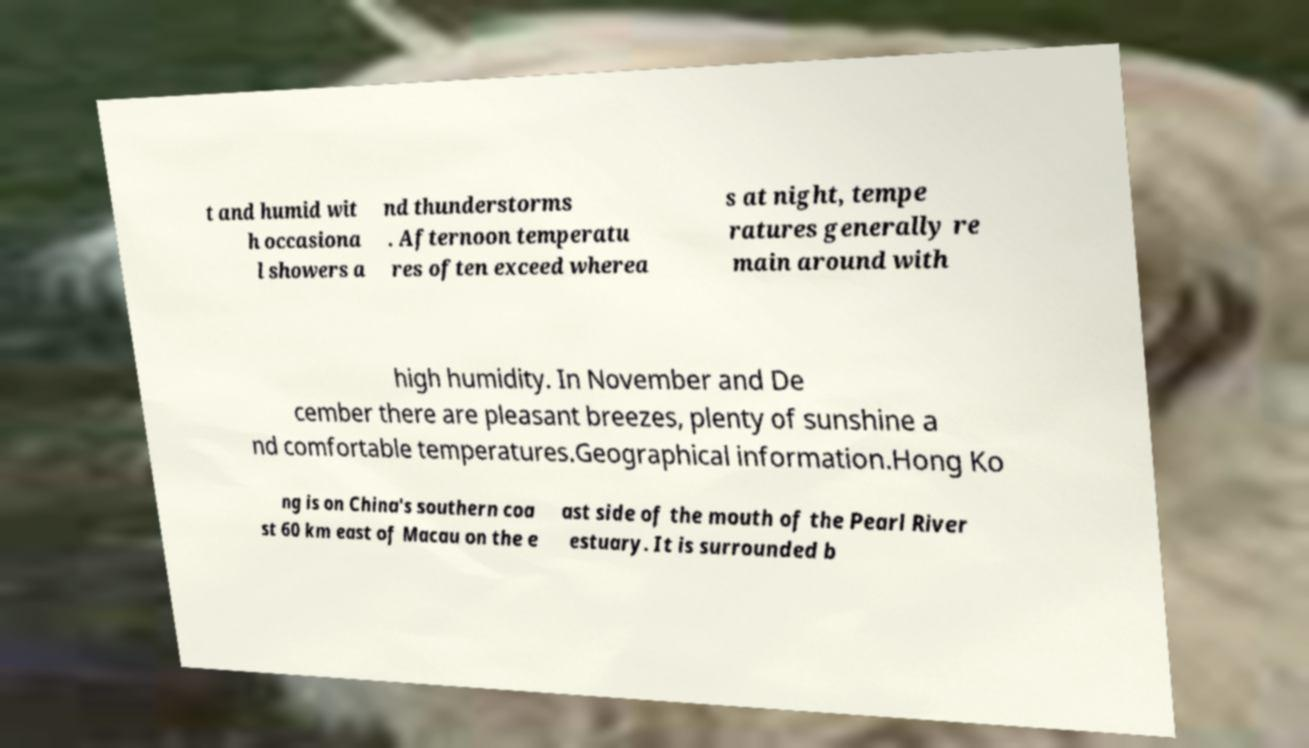There's text embedded in this image that I need extracted. Can you transcribe it verbatim? t and humid wit h occasiona l showers a nd thunderstorms . Afternoon temperatu res often exceed wherea s at night, tempe ratures generally re main around with high humidity. In November and De cember there are pleasant breezes, plenty of sunshine a nd comfortable temperatures.Geographical information.Hong Ko ng is on China's southern coa st 60 km east of Macau on the e ast side of the mouth of the Pearl River estuary. It is surrounded b 